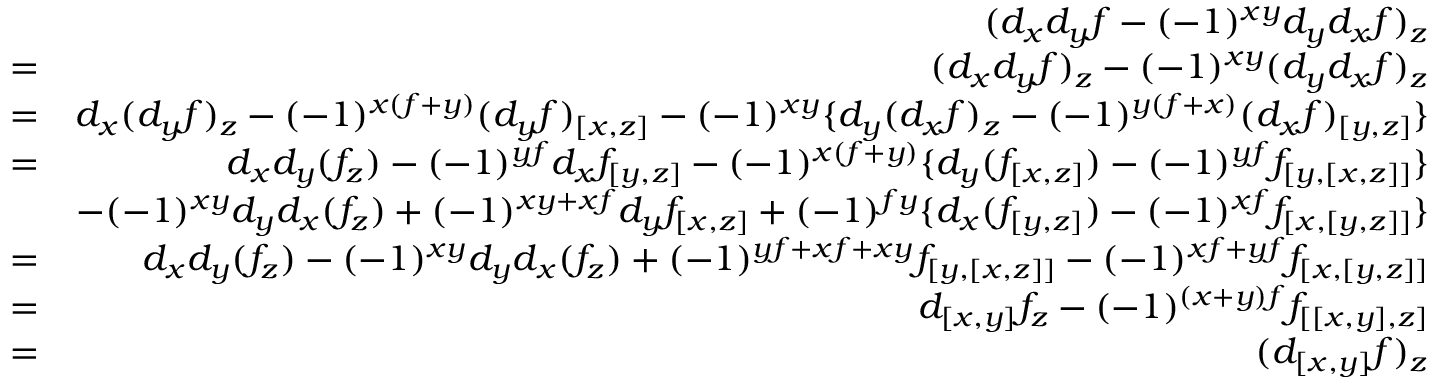<formula> <loc_0><loc_0><loc_500><loc_500>\begin{array} { r l r } & { ( d _ { x } d _ { y } f - ( - 1 ) ^ { x y } d _ { y } d _ { x } f ) _ { z } } \\ & { = } & { ( d _ { x } d _ { y } f ) _ { z } - ( - 1 ) ^ { x y } ( d _ { y } d _ { x } f ) _ { z } } \\ & { = } & { d _ { x } ( d _ { y } f ) _ { z } - ( - 1 ) ^ { x ( f + y ) } ( d _ { y } f ) _ { [ x , z ] } - ( - 1 ) ^ { x y } \{ d _ { y } ( d _ { x } f ) _ { z } - ( - 1 ) ^ { y ( f + x ) } ( d _ { x } f ) _ { [ y , z ] } \} } \\ & { = } & { d _ { x } d _ { y } ( f _ { z } ) - ( - 1 ) ^ { y f } d _ { x } f _ { [ y , z ] } - ( - 1 ) ^ { x ( f + y ) } \{ d _ { y } ( f _ { [ x , z ] } ) - ( - 1 ) ^ { y f } f _ { [ y , [ x , z ] ] } \} } \\ & { - ( - 1 ) ^ { x y } d _ { y } d _ { x } ( f _ { z } ) + ( - 1 ) ^ { x y + x f } d _ { y } f _ { [ x , z ] } + ( - 1 ) ^ { f y } \{ d _ { x } ( f _ { [ y , z ] } ) - ( - 1 ) ^ { x f } f _ { [ x , [ y , z ] ] } \} } \\ & { = } & { d _ { x } d _ { y } ( f _ { z } ) - ( - 1 ) ^ { x y } d _ { y } d _ { x } ( f _ { z } ) + ( - 1 ) ^ { y f + x f + x y } f _ { [ y , [ x , z ] ] } - ( - 1 ) ^ { x f + y f } f _ { [ x , [ y , z ] ] } } \\ & { = } & { d _ { [ x , y ] } f _ { z } - ( - 1 ) ^ { ( x + y ) f } f _ { [ [ x , y ] , z ] } } \\ & { = } & { ( d _ { [ x , y ] } f ) _ { z } } \end{array}</formula> 